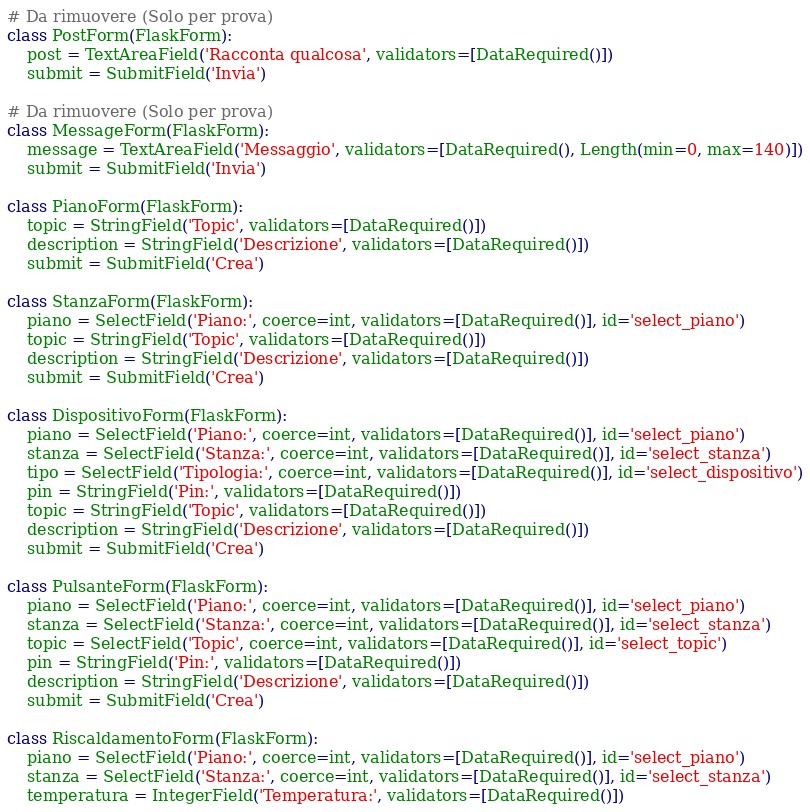Convert code to text. <code><loc_0><loc_0><loc_500><loc_500><_Python_>
# Da rimuovere (Solo per prova)
class PostForm(FlaskForm):
    post = TextAreaField('Racconta qualcosa', validators=[DataRequired()])
    submit = SubmitField('Invia')

# Da rimuovere (Solo per prova)
class MessageForm(FlaskForm):
    message = TextAreaField('Messaggio', validators=[DataRequired(), Length(min=0, max=140)])
    submit = SubmitField('Invia')

class PianoForm(FlaskForm):
    topic = StringField('Topic', validators=[DataRequired()])
    description = StringField('Descrizione', validators=[DataRequired()])
    submit = SubmitField('Crea')

class StanzaForm(FlaskForm):
    piano = SelectField('Piano:', coerce=int, validators=[DataRequired()], id='select_piano')
    topic = StringField('Topic', validators=[DataRequired()])
    description = StringField('Descrizione', validators=[DataRequired()])
    submit = SubmitField('Crea')

class DispositivoForm(FlaskForm):
    piano = SelectField('Piano:', coerce=int, validators=[DataRequired()], id='select_piano')
    stanza = SelectField('Stanza:', coerce=int, validators=[DataRequired()], id='select_stanza')
    tipo = SelectField('Tipologia:', coerce=int, validators=[DataRequired()], id='select_dispositivo')
    pin = StringField('Pin:', validators=[DataRequired()])
    topic = StringField('Topic', validators=[DataRequired()])
    description = StringField('Descrizione', validators=[DataRequired()])
    submit = SubmitField('Crea')

class PulsanteForm(FlaskForm):
    piano = SelectField('Piano:', coerce=int, validators=[DataRequired()], id='select_piano')
    stanza = SelectField('Stanza:', coerce=int, validators=[DataRequired()], id='select_stanza')
    topic = SelectField('Topic', coerce=int, validators=[DataRequired()], id='select_topic')
    pin = StringField('Pin:', validators=[DataRequired()])
    description = StringField('Descrizione', validators=[DataRequired()])
    submit = SubmitField('Crea')

class RiscaldamentoForm(FlaskForm):
    piano = SelectField('Piano:', coerce=int, validators=[DataRequired()], id='select_piano')
    stanza = SelectField('Stanza:', coerce=int, validators=[DataRequired()], id='select_stanza')
    temperatura = IntegerField('Temperatura:', validators=[DataRequired()])</code> 